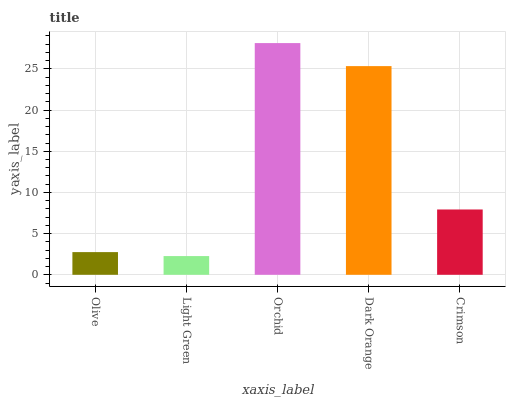Is Orchid the minimum?
Answer yes or no. No. Is Light Green the maximum?
Answer yes or no. No. Is Orchid greater than Light Green?
Answer yes or no. Yes. Is Light Green less than Orchid?
Answer yes or no. Yes. Is Light Green greater than Orchid?
Answer yes or no. No. Is Orchid less than Light Green?
Answer yes or no. No. Is Crimson the high median?
Answer yes or no. Yes. Is Crimson the low median?
Answer yes or no. Yes. Is Light Green the high median?
Answer yes or no. No. Is Olive the low median?
Answer yes or no. No. 